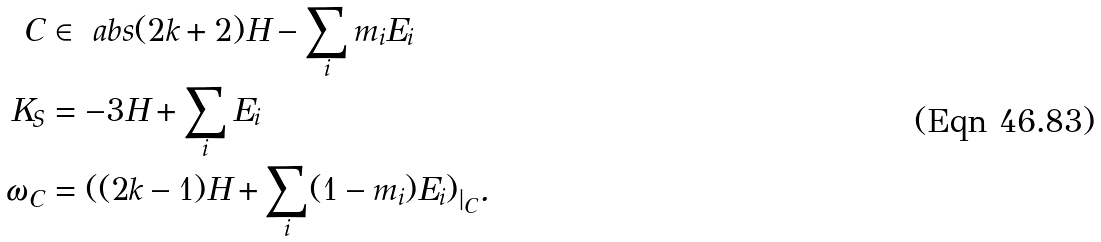<formula> <loc_0><loc_0><loc_500><loc_500>C & \in \ a b s { ( 2 k + 2 ) H - \sum _ { i } m _ { i } E _ { i } } \\ K _ { S } & = - 3 H + \sum _ { i } E _ { i } \\ \omega _ { C } & = ( ( 2 k - 1 ) H + \sum _ { i } ( 1 - m _ { i } ) E _ { i } ) _ { | _ { C } } .</formula> 